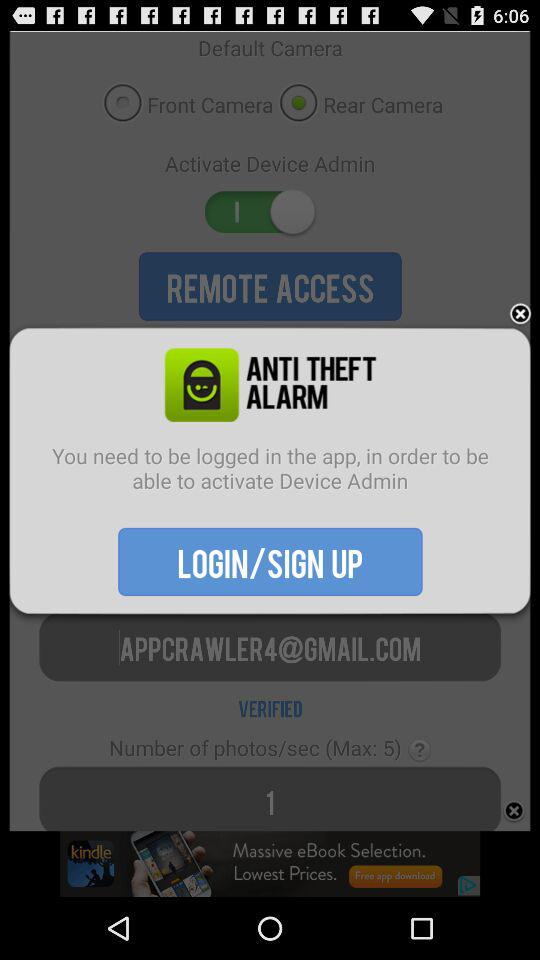What is the application name? The application name is "ANTI THEFT ALARM". 